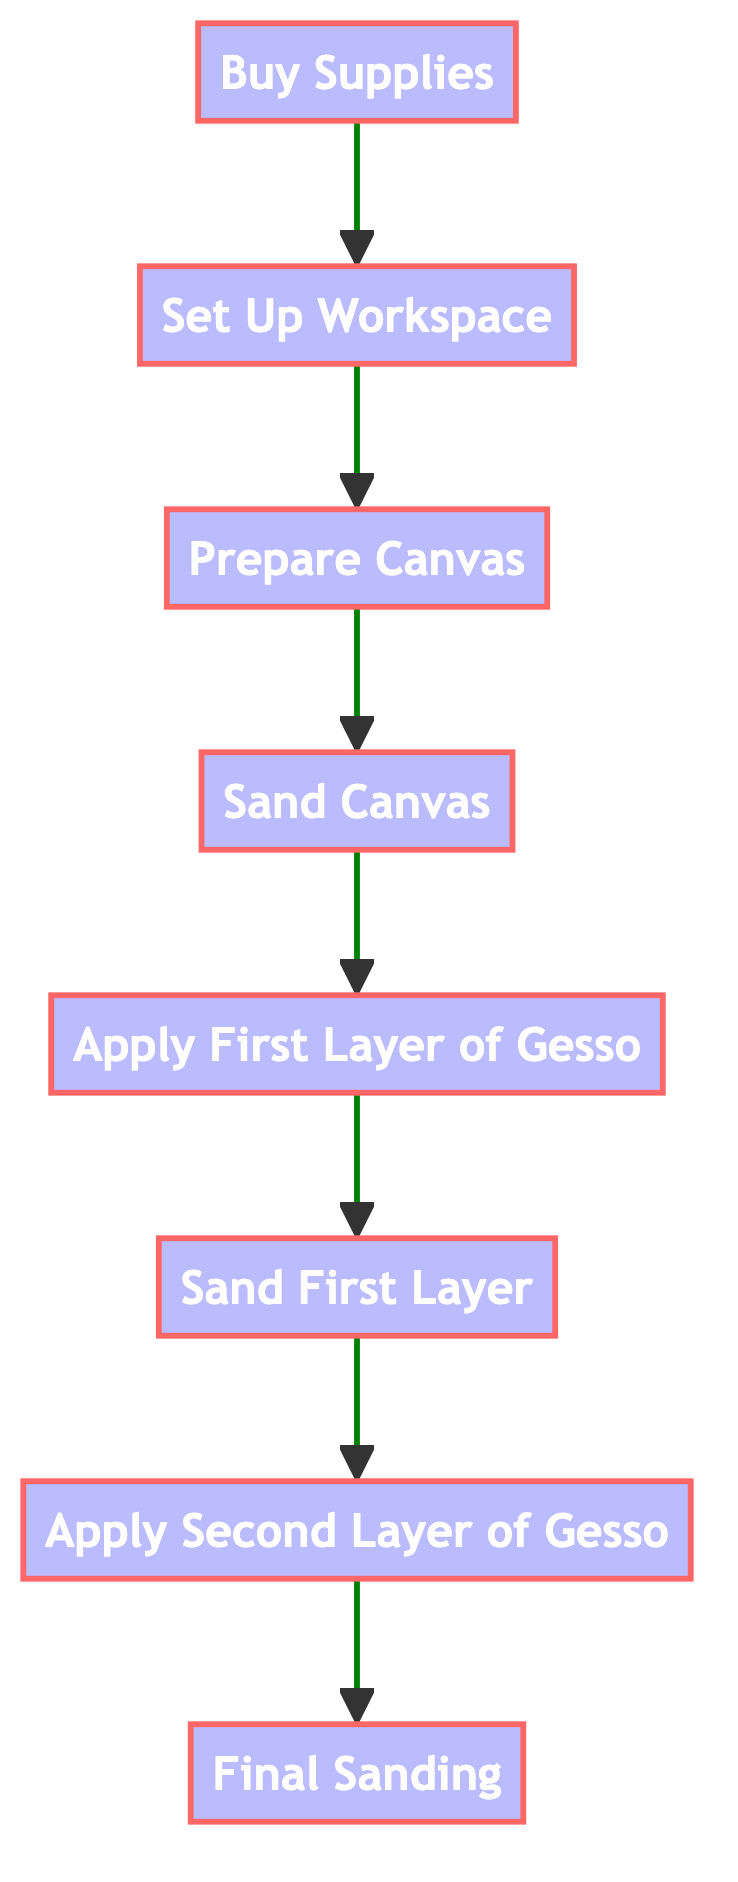What is the first step in the process? The flowchart starts with "Buy Supplies" as the first step before any other preparation can begin.
Answer: Buy Supplies How many steps are there to prepare the canvas? Counting all the unique nodes in the flowchart, there are a total of 8 steps listed from "Buy Supplies" to "Final Sanding".
Answer: Eight What is the last step before the canvas is ready for painting? The last step in the flowchart is "Final Sanding", which comes right before the canvas is ready for use.
Answer: Final Sanding Which step follows "Sand Canvas"? After "Sand Canvas", the next step indicated in the flow is "Apply First Layer of Gesso".
Answer: Apply First Layer of Gesso What two steps must be completed before applying the second layer of gesso? To apply the "Apply Second Layer of Gesso", the preceding required steps are "Sand First Layer" and "Apply First Layer of Gesso".
Answer: Sand First Layer, Apply First Layer of Gesso How many layers of gesso are applied during the process? Referring to the flowchart, there are two layers of gesso that are applied to the canvas—first and second layer—shown in the steps.
Answer: Two layers What is the relationship between "Prepare Canvas" and "Set Up Workspace"? "Prepare Canvas" is dependent on having "Set Up Workspace" completed first, indicating a flow from the latter to the former.
Answer: "Prepare Canvas" depends on "Set Up Workspace" How many times is the canvas sanded in this process? The flowchart indicates that the canvas is sanded three times throughout the preparation: "Sand Canvas", "Sand First Layer", and "Final Sanding".
Answer: Three times 